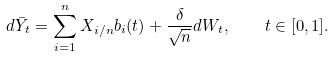<formula> <loc_0><loc_0><loc_500><loc_500>d \bar { Y } _ { t } = \sum _ { i = 1 } ^ { n } X _ { i / n } b _ { i } ( t ) + \frac { \delta } { \sqrt { n } } d W _ { t } , \quad t \in [ 0 , 1 ] .</formula> 